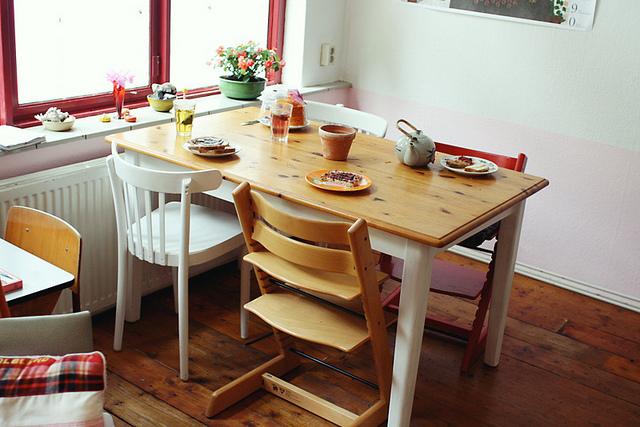How many chairs match the table top?
Concise answer only. 1. What foods are placed on the table?
Write a very short answer. Breakfast. What color is the window will?
Write a very short answer. Red. 